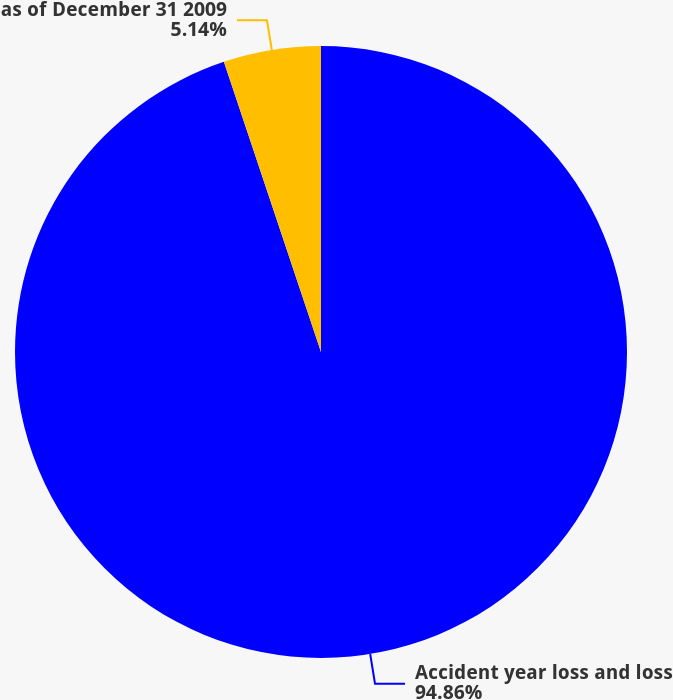Convert chart to OTSL. <chart><loc_0><loc_0><loc_500><loc_500><pie_chart><fcel>Accident year loss and loss<fcel>as of December 31 2009<nl><fcel>94.86%<fcel>5.14%<nl></chart> 